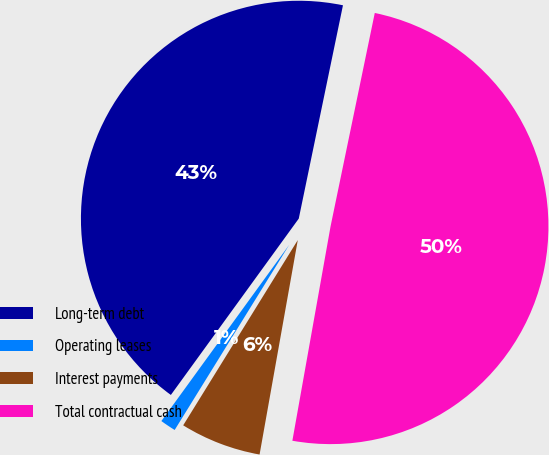<chart> <loc_0><loc_0><loc_500><loc_500><pie_chart><fcel>Long-term debt<fcel>Operating leases<fcel>Interest payments<fcel>Total contractual cash<nl><fcel>43.26%<fcel>1.17%<fcel>6.01%<fcel>49.55%<nl></chart> 